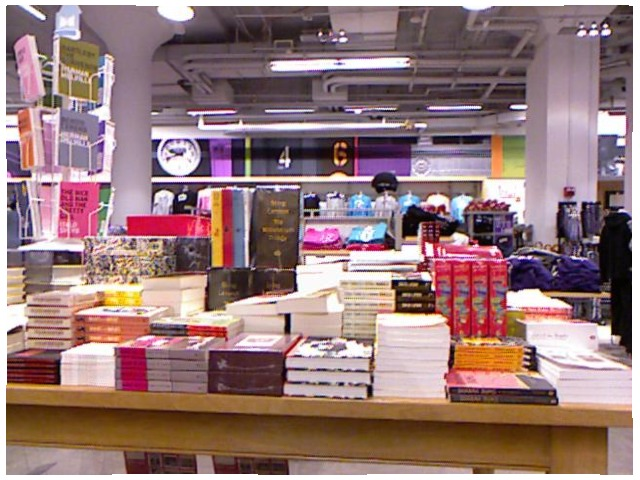<image>
Is there a books on the book? Yes. Looking at the image, I can see the books is positioned on top of the book, with the book providing support. Is the books on the table? Yes. Looking at the image, I can see the books is positioned on top of the table, with the table providing support. 